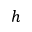<formula> <loc_0><loc_0><loc_500><loc_500>h</formula> 